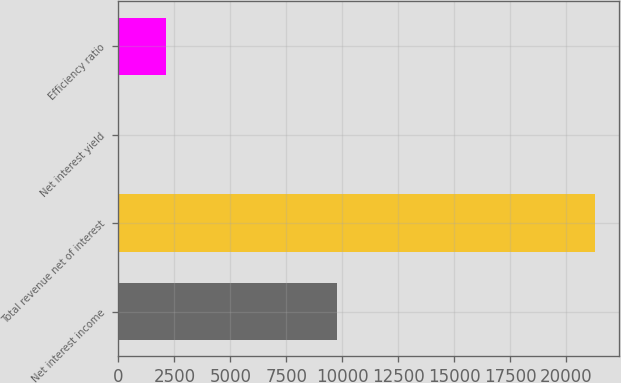Convert chart. <chart><loc_0><loc_0><loc_500><loc_500><bar_chart><fcel>Net interest income<fcel>Total revenue net of interest<fcel>Net interest yield<fcel>Efficiency ratio<nl><fcel>9739<fcel>21262<fcel>2.16<fcel>2128.14<nl></chart> 